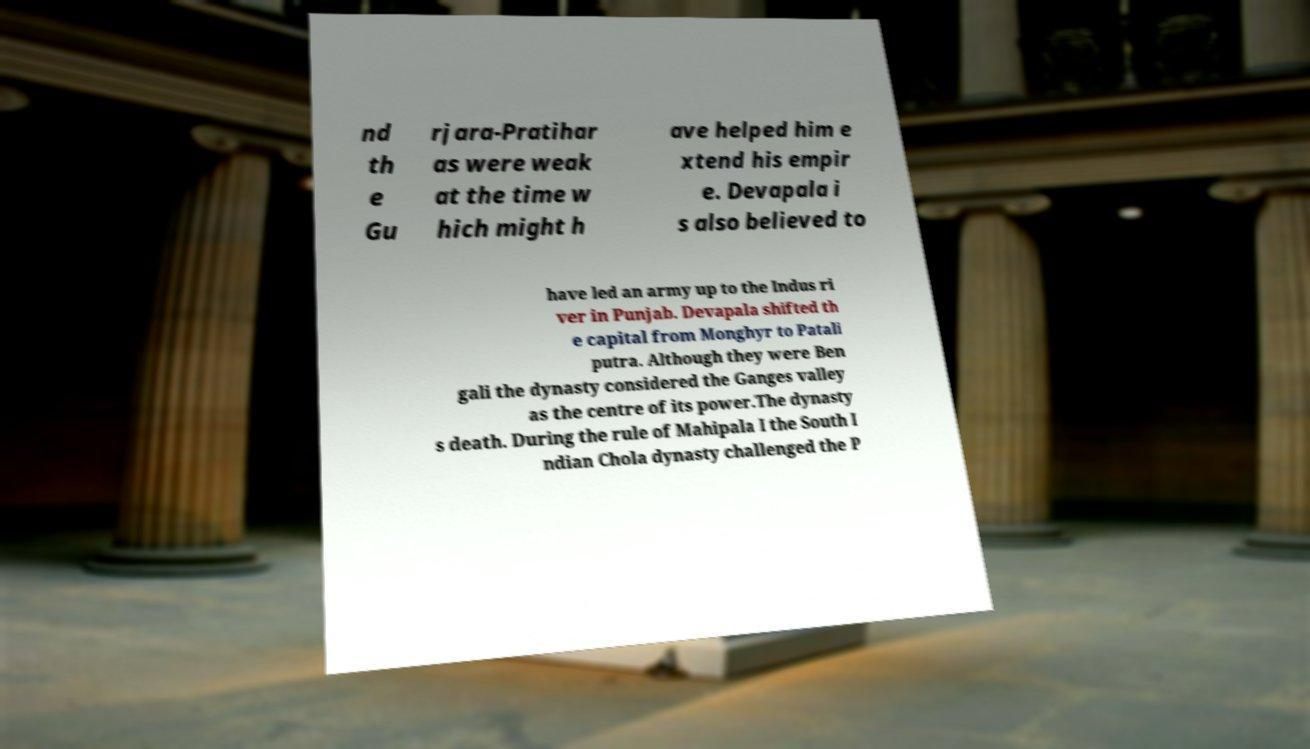Can you accurately transcribe the text from the provided image for me? nd th e Gu rjara-Pratihar as were weak at the time w hich might h ave helped him e xtend his empir e. Devapala i s also believed to have led an army up to the Indus ri ver in Punjab. Devapala shifted th e capital from Monghyr to Patali putra. Although they were Ben gali the dynasty considered the Ganges valley as the centre of its power.The dynasty s death. During the rule of Mahipala I the South I ndian Chola dynasty challenged the P 